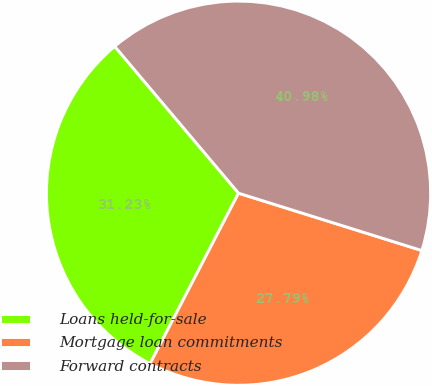Convert chart. <chart><loc_0><loc_0><loc_500><loc_500><pie_chart><fcel>Loans held-for-sale<fcel>Mortgage loan commitments<fcel>Forward contracts<nl><fcel>31.23%<fcel>27.79%<fcel>40.98%<nl></chart> 